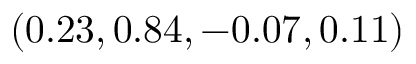Convert formula to latex. <formula><loc_0><loc_0><loc_500><loc_500>( 0 . 2 3 , 0 . 8 4 , - 0 . 0 7 , 0 . 1 1 )</formula> 